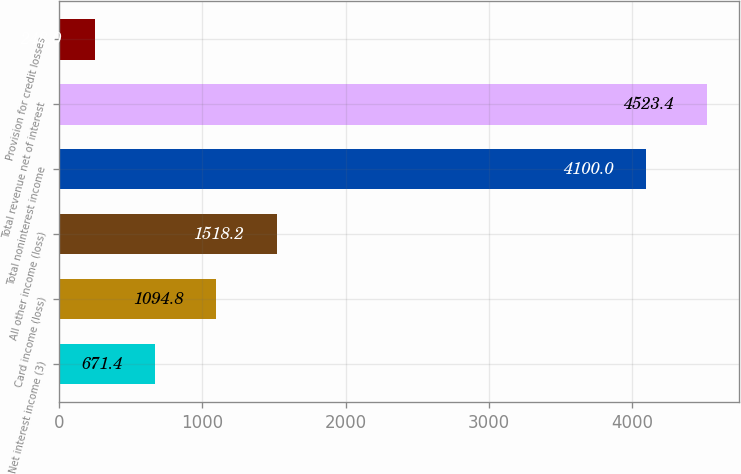Convert chart to OTSL. <chart><loc_0><loc_0><loc_500><loc_500><bar_chart><fcel>Net interest income (3)<fcel>Card income (loss)<fcel>All other income (loss)<fcel>Total noninterest income<fcel>Total revenue net of interest<fcel>Provision for credit losses<nl><fcel>671.4<fcel>1094.8<fcel>1518.2<fcel>4100<fcel>4523.4<fcel>248<nl></chart> 